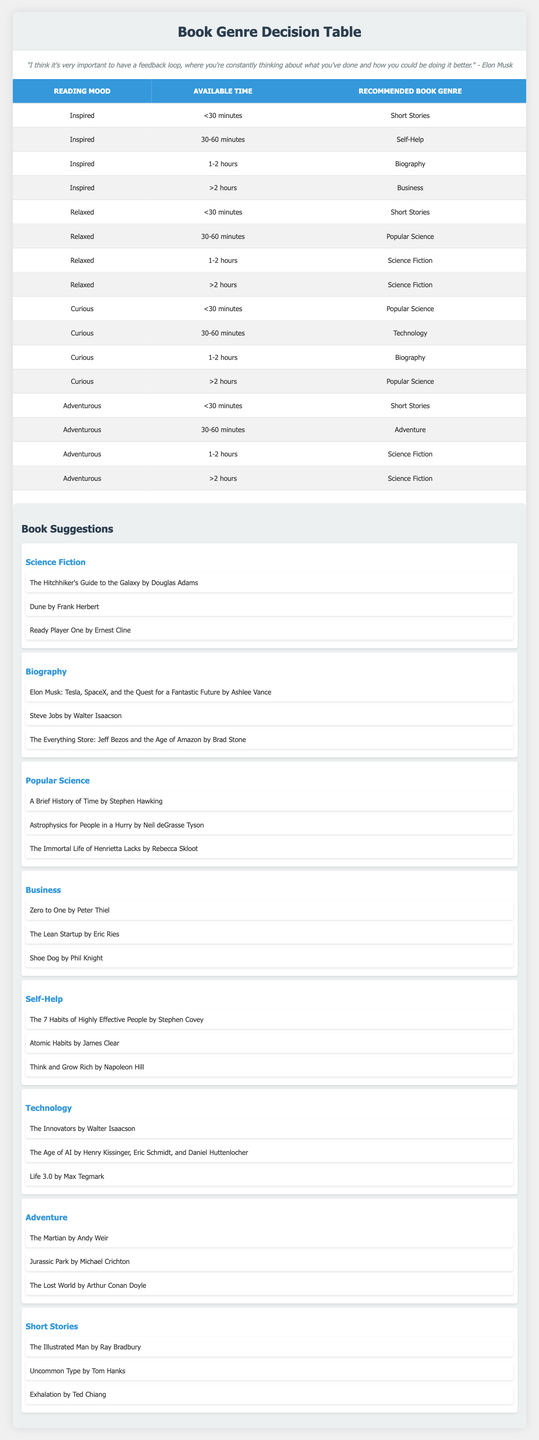What book genre is recommended for someone who is inspired and has less than 30 minutes to read? According to the table, if a person is inspired and has less than 30 minutes, the recommended book genre is Short Stories. This can be found in the first row of the table where the conditions match.
Answer: Short Stories If someone is curious and has 30-60 minutes to read, what genre should they choose? From the table, the recommendation for a person who is curious and has 30-60 minutes to read is Technology. This can be identified in the relevant row under the Curious mood and the specified time slot.
Answer: Technology Is Science Fiction recommended for a relaxed reading mood? Yes. The table indicates that for both 1-2 hours and greater than 2 hours of available time while feeling relaxed, the recommended genre is Science Fiction. This verification checks both time slots under the Relaxed mood.
Answer: Yes What is the recommended book genre for a relaxed person who has 30-60 minutes available? For someone who is relaxed and has 30-60 minutes, the table shows that the recommended genre is Popular Science, as indicated in the relevant row of the table.
Answer: Popular Science For how many conditions does the genre Biography appear in the table? The genre Biography appears in the conditions for Inspired with 1-2 hours of available time and for Curious with 1-2 hours of available time. Thus, it appears twice in the table across different moods, which are identified by looking at all the rows for occurrences of Biography.
Answer: 2 Which genre appears most frequently in the table? By analyzing the table, while checking each row, it is found that Science Fiction appears most frequently (4 times) across various moods and time slots. This requires counting instances for each genre listed in the action column.
Answer: Science Fiction If a person's reading mood is adventurous with only 30-60 minutes available, what will be the book genre? The table specifies that for an adventurous mood with 30-60 minutes available, the recommended book genre is Adventure. This is found in the relevant row depicting these conditions.
Answer: Adventure Can someone who is inspired for more than 2 hours read Science Fiction? No. According to the table, an inspired person with more than 2 hours would be recommended to read Business, not Science Fiction. This is evident when matching the conditions with the genre recommendations.
Answer: No 